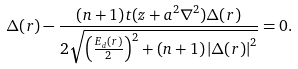Convert formula to latex. <formula><loc_0><loc_0><loc_500><loc_500>\Delta ( r ) - \frac { ( n + 1 ) t ( z + a ^ { 2 } \nabla ^ { 2 } ) \Delta ( r ) } { 2 \sqrt { \left ( \frac { E _ { d } ( r ) } { 2 } \right ) ^ { 2 } + ( n + 1 ) \left | \Delta ( r ) \right | ^ { 2 } } } = 0 .</formula> 